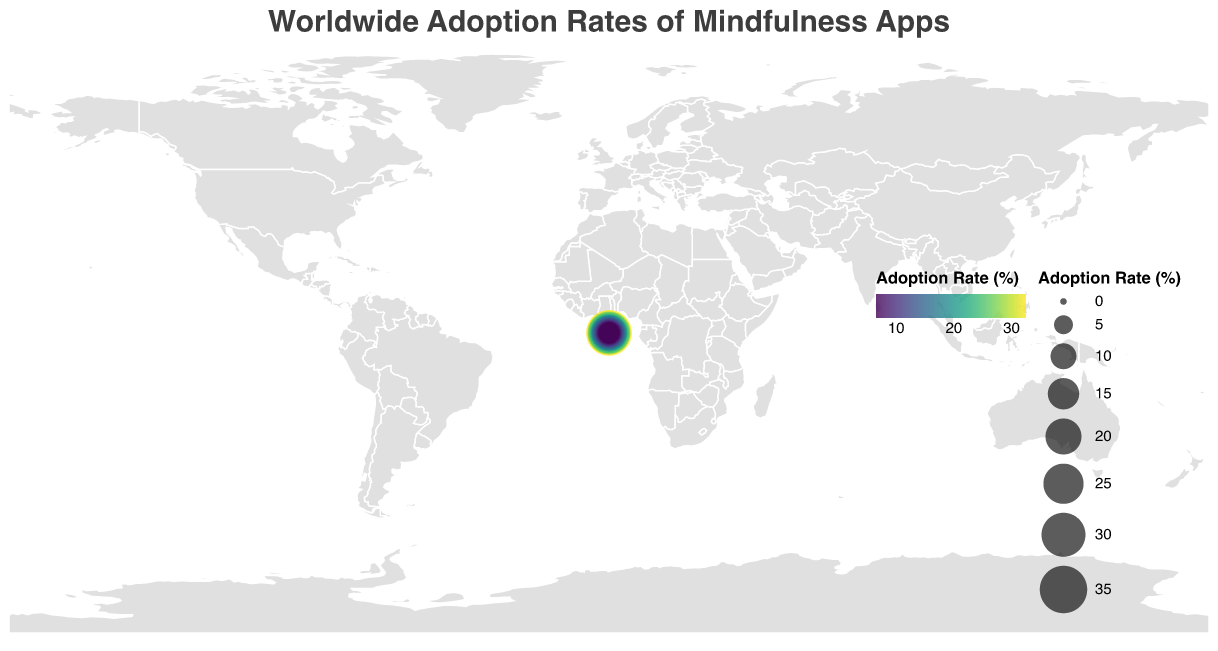What is the highest adoption rate of mindfulness apps and which country does it belong to? The figure's tooltip displays the adoption rate for each country. The highest adoption rate shown is 32.5%, belonging to the United States.
Answer: United States How are the colors used to represent adoption rates in the figure? The figure uses a color scale (viridis) to represent adoption rates, where different shades from the scale indicate varying levels of adoption. Darker shades generally represent higher adoption rates, and lighter shades represent lower rates.
Answer: Color scale (viridis) Which country has the lowest adoption rate of mindfulness apps? By comparing the adoption rates in the tooltip from each country, the lowest adoption rate is 6.5%, which belongs to Indonesia.
Answer: Indonesia What is the difference in adoption rates between the United States and China? The United States has an adoption rate of 32.5%, and China has 7.9%. Subtracting the rate of China from that of the United States gives 32.5% - 7.9% = 24.6%.
Answer: 24.6% How many countries have adoption rates below 10%? By looking at the adoption rates displayed in the figure, there are four countries with adoption rates below 10%: Singapore (9.8%), Russia (8.6%), China (7.9%), and Indonesia (6.5%).
Answer: 4 What does the size of the circles represent in the figure? The size of the circles in the figure is proportional to the adoption rates of mindfulness apps, with larger circles indicating higher adoption rates.
Answer: Adoption rates What is the combined adoption rate for Germany and France? Germany’s adoption rate is 21.8%, and France’s is 19.6%. Adding these rates together results in 21.8% + 19.6% = 41.4%.
Answer: 41.4% Which countries have adoption rates between 15% and 20%? From the figure, the countries with adoption rates in the 15%-20% range are: Germany (21.8%), France (19.6%), Japan (18.2%), Netherlands (17.9%), Sweden (16.5%), and India (15.8%).
Answer: 6 countries: Germany, France, Japan, Netherlands, Sweden, India 